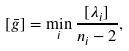Convert formula to latex. <formula><loc_0><loc_0><loc_500><loc_500>[ \bar { g } ] = \min _ { i } \frac { [ \lambda _ { i } ] } { n _ { i } - 2 } ,</formula> 